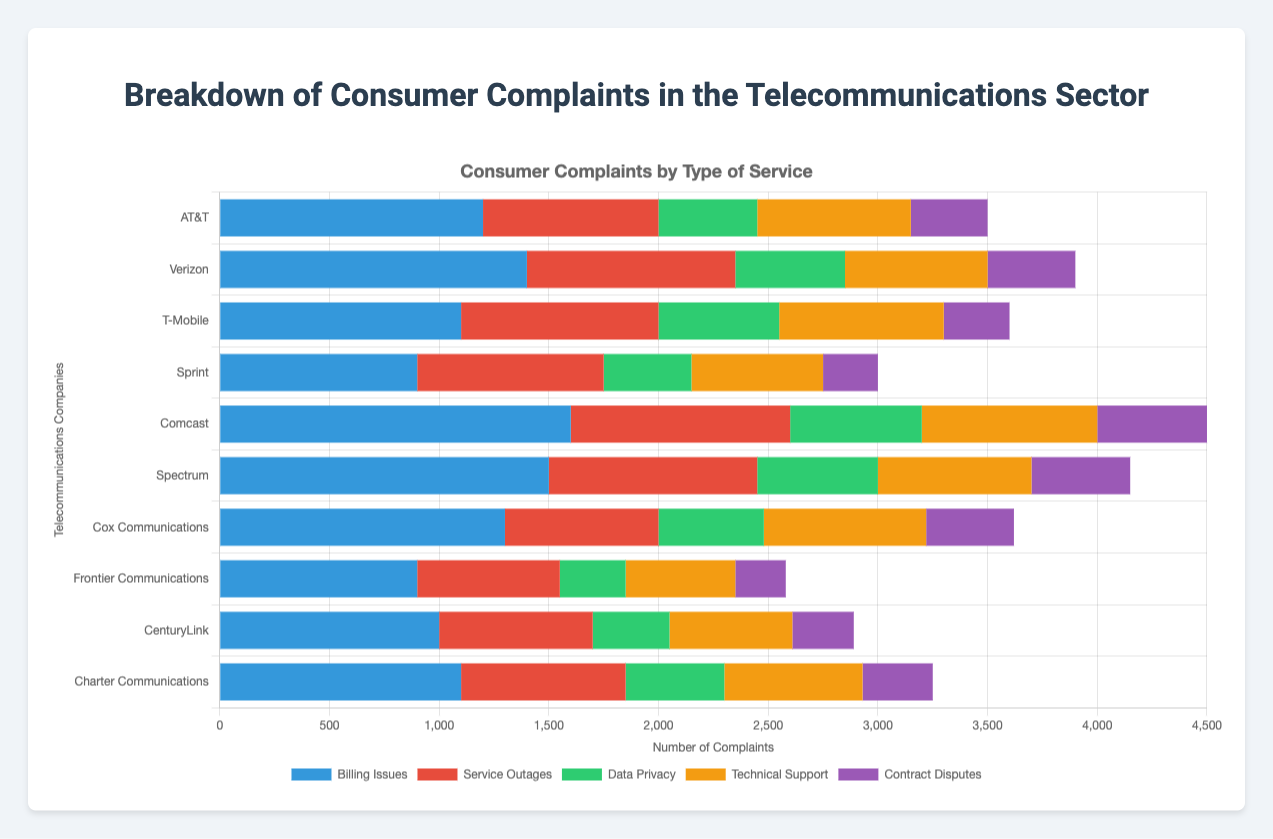Which company has the highest number of data privacy complaints? By examining the green sections of the bars representing data privacy complaints, we find the highest value is for Comcast.
Answer: Comcast What is the total number of service outages complaints for AT&T and Verizon combined? AT&T has 800 service outages complaints, and Verizon has 950. Adding these together, 800 + 950 = 1750.
Answer: 1750 Which company has fewer billing issues complaints compared to technical support complaints? Frontier Communications has 900 billing issues and 500 technical support complaints, indicating fewer technical support complaints compared to billing issues.
Answer: Frontier Communications Which category has the highest number of complaints for Spectrum? In Spectrum's bar, the largest segment is blue, which represents billing issues, with 1500 complaints.
Answer: Billing Issues What is the average number of contract disputes complaints across all companies? Summing up contract disputes complaints (350 + 400 + 300 + 250 + 500 + 450 + 400 + 230 + 280 + 320) gives 3480. Dividing by 10 companies, 3480 / 10 = 348.
Answer: 348 Which company shows a similar scale of complaints for billing issues and service outages? By comparing the lengths of the blue and red segments, CenturyLink has 1000 billing issues and 700 service outages complaints, which are relatively close in value.
Answer: CenturyLink Between T-Mobile and Sprint, which company has a higher total number of complaints across all categories? Summing up the complaints for T-Mobile (1100 + 900 + 550 + 750 + 300 = 3600) and Sprint (900 + 850 + 400 + 600 + 250 = 3000), T-Mobile has more.
Answer: T-Mobile Rank the companies by the number of data privacy complaints from highest to lowest. By examining the green segments, the order is: Comcast (600), Spectrum (550), T-Mobile (550), Verizon (500), Cox Communications (480), AT&T (450), Charter Communications (450), CenturyLink (350), Sprint (400), Frontier Communications (300).
Answer: Comcast > Spectrum = T-Mobile > Verizon > Cox Communications > AT&T = Charter Communications > Sprint > CenturyLink > Frontier Communications How many companies have more than 800 billing issues complaints? By examining the blue segments for billing issues, we see AT&T (1200), Verizon (1400), T-Mobile (1100), Comcast (1600), Spectrum (1500), Cox Communications (1300), CenturyLink (1000), and Charter Communications (1100) all have more than 800 billing issues complaints, totaling 8 companies.
Answer: 8 What is the combined total number of technical support complaints for Comcast, Spectrum, and Cox Communications? Adding technical support complaints for Comcast (800), Spectrum (700), and Cox Communications (740), we get 800 + 700 + 740 = 2240.
Answer: 2240 